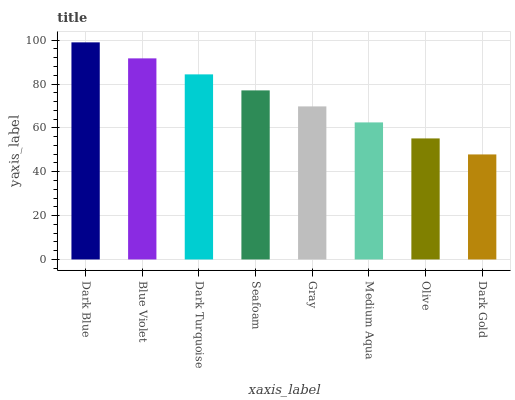Is Dark Gold the minimum?
Answer yes or no. Yes. Is Dark Blue the maximum?
Answer yes or no. Yes. Is Blue Violet the minimum?
Answer yes or no. No. Is Blue Violet the maximum?
Answer yes or no. No. Is Dark Blue greater than Blue Violet?
Answer yes or no. Yes. Is Blue Violet less than Dark Blue?
Answer yes or no. Yes. Is Blue Violet greater than Dark Blue?
Answer yes or no. No. Is Dark Blue less than Blue Violet?
Answer yes or no. No. Is Seafoam the high median?
Answer yes or no. Yes. Is Gray the low median?
Answer yes or no. Yes. Is Dark Gold the high median?
Answer yes or no. No. Is Medium Aqua the low median?
Answer yes or no. No. 